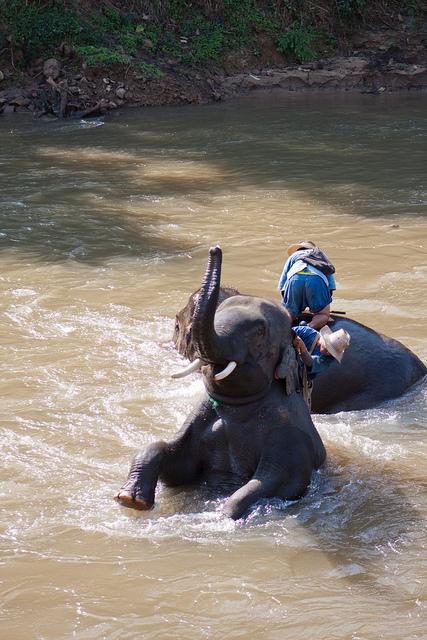Is the elephant taking a bath?
Write a very short answer. Yes. Is the elephant's trunk point upward?
Give a very brief answer. Yes. What age is the man riding the elephant?
Be succinct. 30. Is someone in the water with the elephant?
Keep it brief. Yes. 